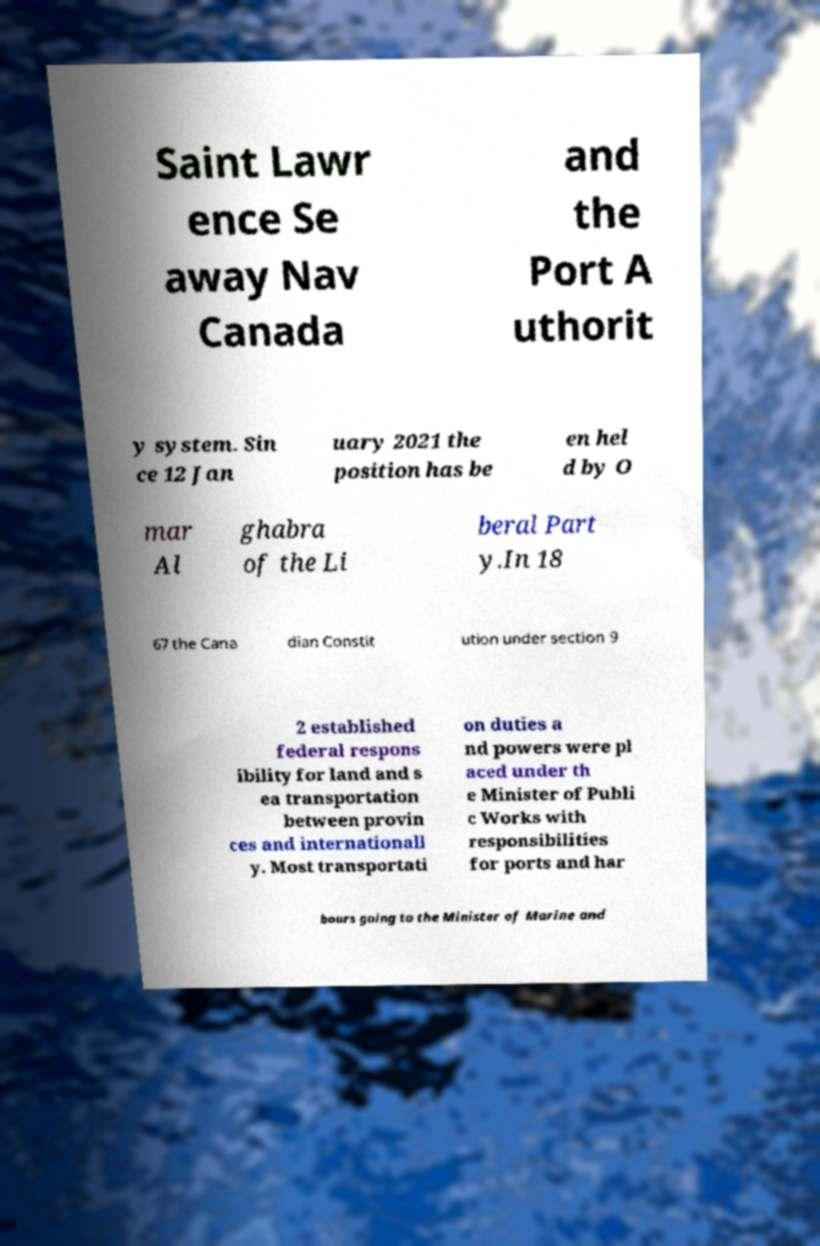Can you read and provide the text displayed in the image?This photo seems to have some interesting text. Can you extract and type it out for me? Saint Lawr ence Se away Nav Canada and the Port A uthorit y system. Sin ce 12 Jan uary 2021 the position has be en hel d by O mar Al ghabra of the Li beral Part y.In 18 67 the Cana dian Constit ution under section 9 2 established federal respons ibility for land and s ea transportation between provin ces and internationall y. Most transportati on duties a nd powers were pl aced under th e Minister of Publi c Works with responsibilities for ports and har bours going to the Minister of Marine and 